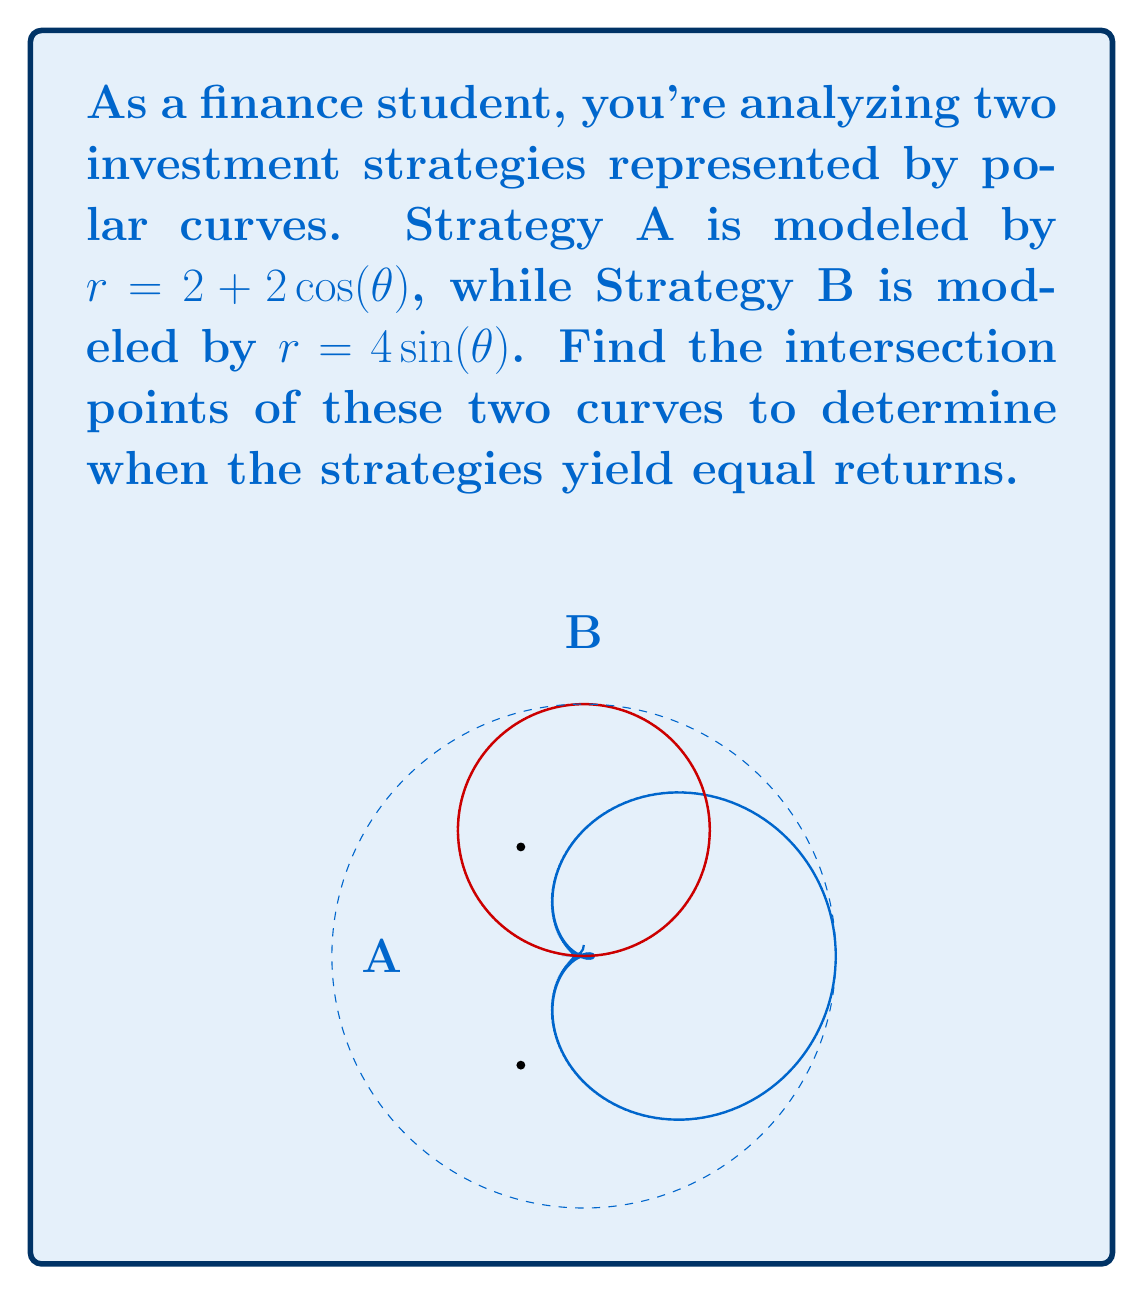Help me with this question. To find the intersection points, we need to solve the equation:

$$ 2 + 2\cos(\theta) = 4\sin(\theta) $$

1) First, let's square both sides to eliminate the square root:

   $$ (2 + 2\cos(\theta))^2 = (4\sin(\theta))^2 $$

2) Expand the left side:

   $$ 4 + 8\cos(\theta) + 4\cos^2(\theta) = 16\sin^2(\theta) $$

3) Use the identity $\sin^2(\theta) + \cos^2(\theta) = 1$ to replace $\sin^2(\theta)$:

   $$ 4 + 8\cos(\theta) + 4\cos^2(\theta) = 16(1 - \cos^2(\theta)) $$

4) Expand the right side:

   $$ 4 + 8\cos(\theta) + 4\cos^2(\theta) = 16 - 16\cos^2(\theta) $$

5) Rearrange terms:

   $$ 20\cos^2(\theta) + 8\cos(\theta) - 12 = 0 $$

6) This is a quadratic in $\cos(\theta)$. Solve using the quadratic formula:

   $$ \cos(\theta) = \frac{-8 \pm \sqrt{64 + 960}}{40} = \frac{-8 \pm \sqrt{1024}}{40} = \frac{-8 \pm 32}{40} $$

7) Simplify:

   $$ \cos(\theta) = \frac{-1 \pm 4}{5} $$

8) This gives us two solutions:

   $$ \cos(\theta) = \frac{3}{5} \text{ or } \cos(\theta) = -\frac{1}{5} $$

9) Convert to angles:

   $$ \theta = \arccos(\frac{3}{5}) \approx 0.9273 \text{ radians} \approx 53.13° $$
   $$ \theta = \arccos(-\frac{1}{5}) \approx 1.7722 \text{ radians} \approx 101.54° $$

10) Due to symmetry, we also have solutions at $-53.13°$ and $258.46°$.

11) Convert to Cartesian coordinates:

    For $\theta = 53.13°$: $(2, 2\sqrt{3})$
    For $\theta = 101.54°$: $(-2, 2\sqrt{3})$
    For $\theta = -53.13°$: $(2, -2\sqrt{3})$
    For $\theta = 258.46°$: $(-2, -2\sqrt{3})$
Answer: $(2, 2\sqrt{3})$, $(-2, 2\sqrt{3})$, $(2, -2\sqrt{3})$, $(-2, -2\sqrt{3})$ 